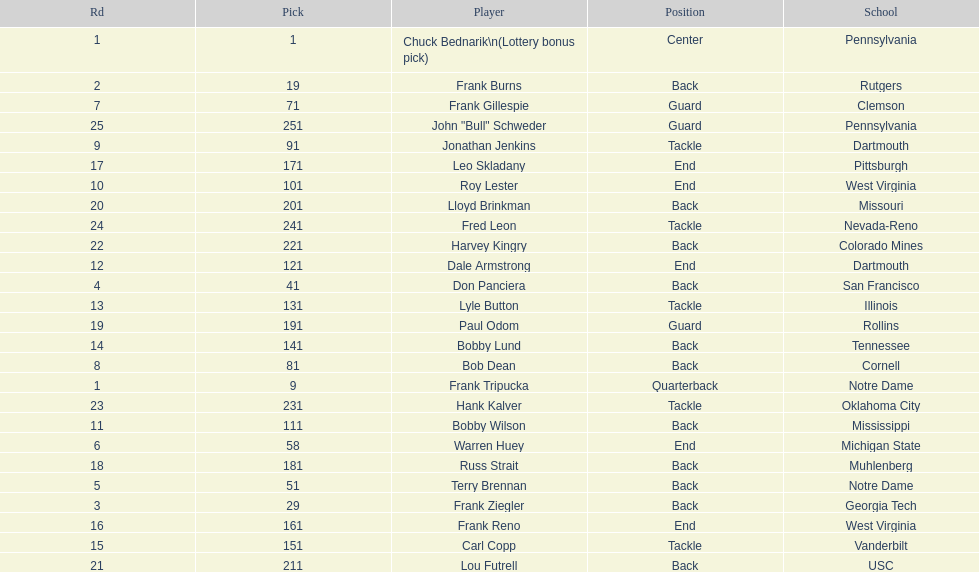Who was picked after frank burns? Frank Ziegler. 